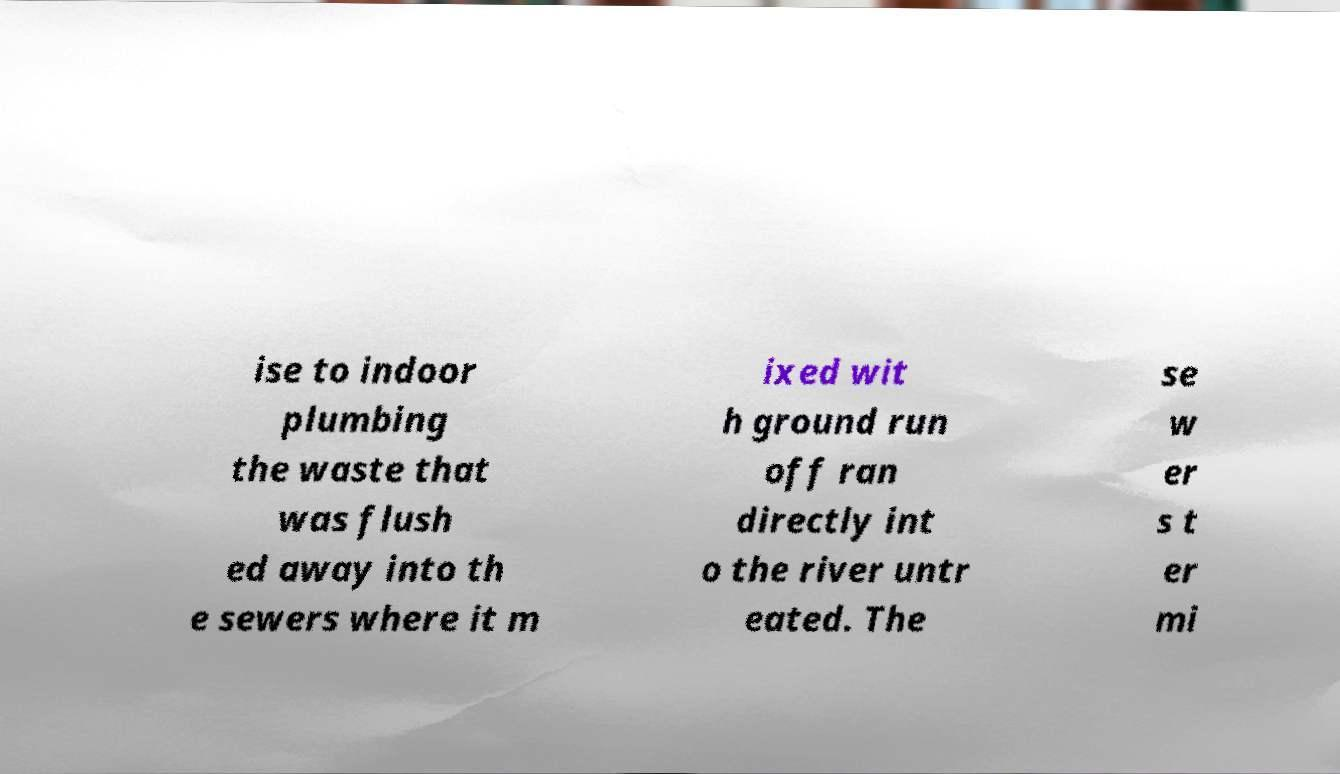Can you read and provide the text displayed in the image?This photo seems to have some interesting text. Can you extract and type it out for me? ise to indoor plumbing the waste that was flush ed away into th e sewers where it m ixed wit h ground run off ran directly int o the river untr eated. The se w er s t er mi 